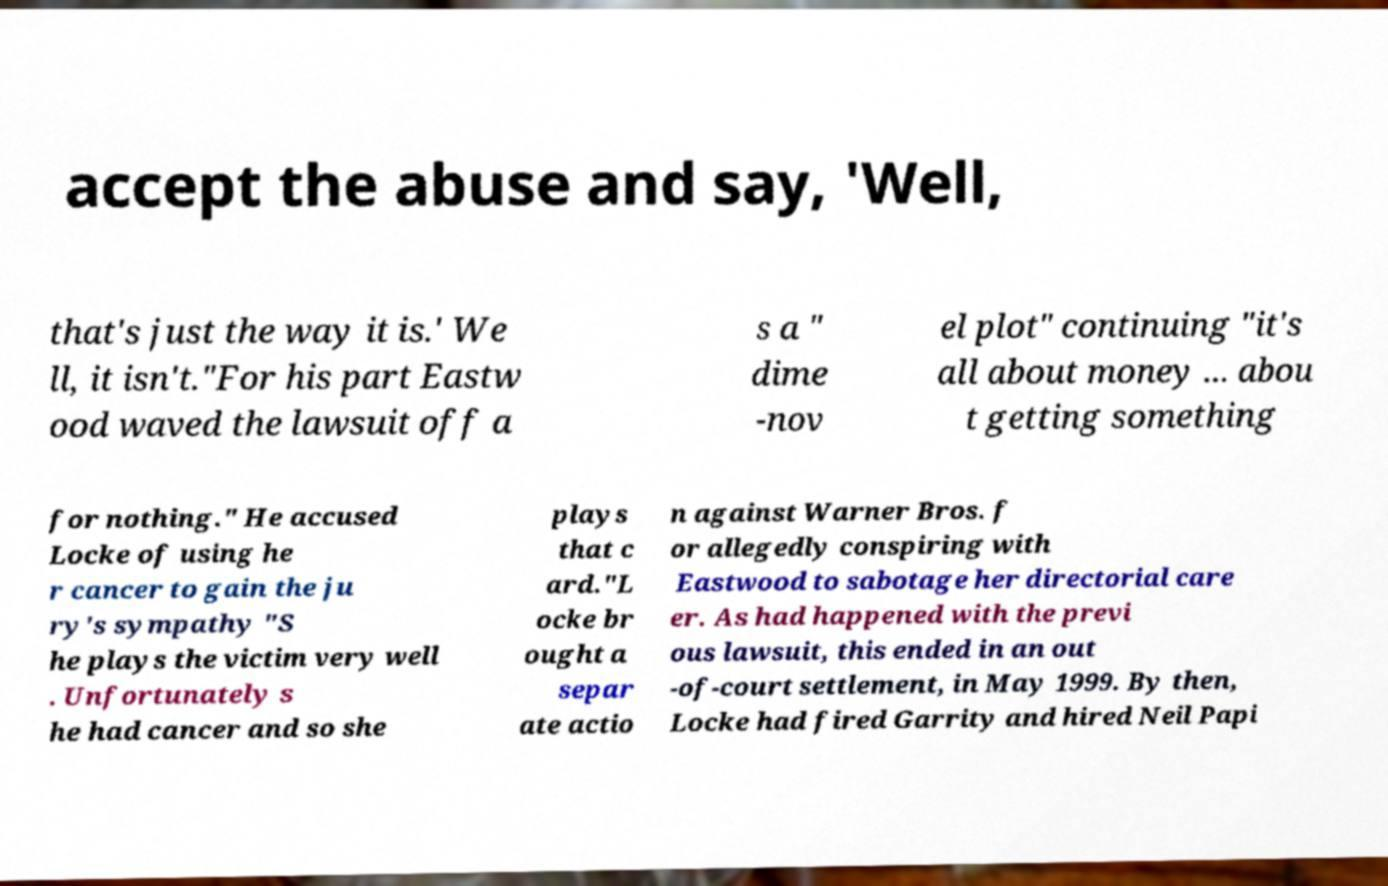Can you accurately transcribe the text from the provided image for me? accept the abuse and say, 'Well, that's just the way it is.' We ll, it isn't."For his part Eastw ood waved the lawsuit off a s a " dime -nov el plot" continuing "it's all about money ... abou t getting something for nothing." He accused Locke of using he r cancer to gain the ju ry's sympathy "S he plays the victim very well . Unfortunately s he had cancer and so she plays that c ard."L ocke br ought a separ ate actio n against Warner Bros. f or allegedly conspiring with Eastwood to sabotage her directorial care er. As had happened with the previ ous lawsuit, this ended in an out -of-court settlement, in May 1999. By then, Locke had fired Garrity and hired Neil Papi 